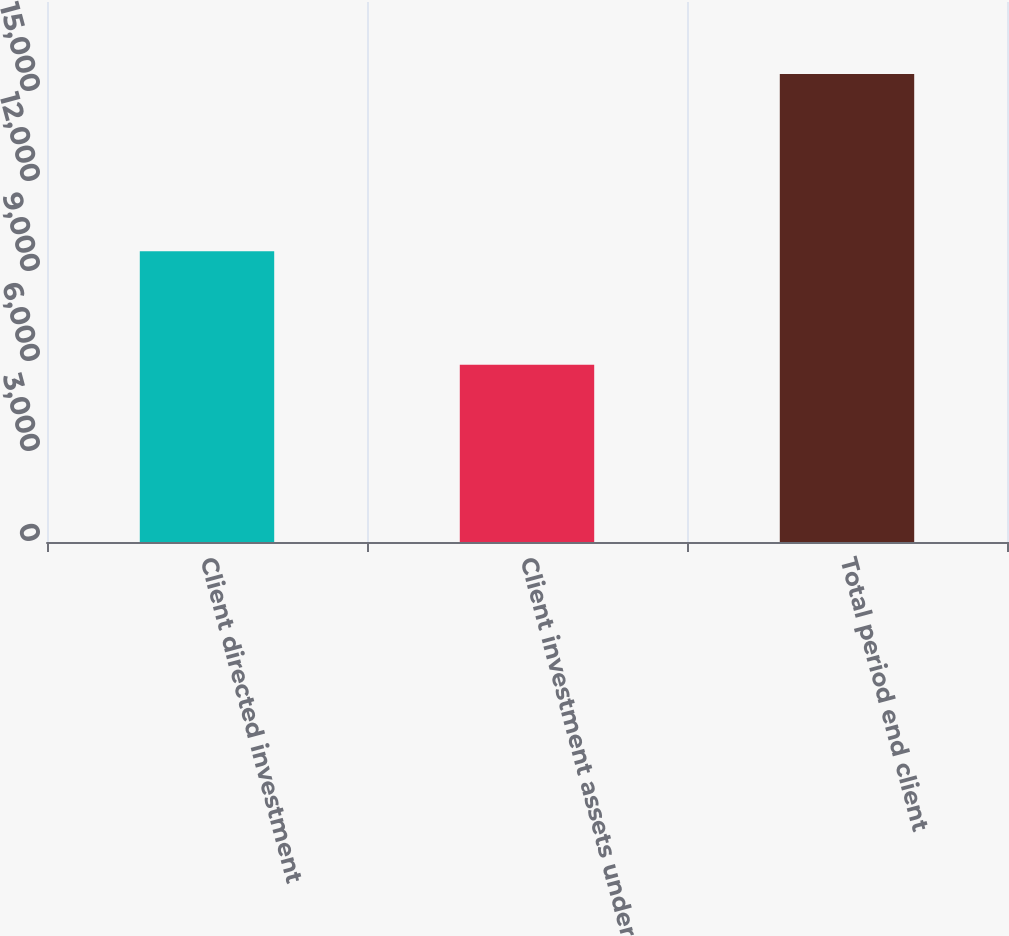<chart> <loc_0><loc_0><loc_500><loc_500><bar_chart><fcel>Client directed investment<fcel>Client investment assets under<fcel>Total period end client<nl><fcel>9693<fcel>5905<fcel>15598<nl></chart> 